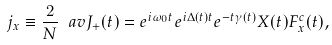Convert formula to latex. <formula><loc_0><loc_0><loc_500><loc_500>j _ { x } \equiv \frac { 2 } { N } \ a v { J _ { + } ( t ) } = e ^ { i \omega _ { 0 } t } e ^ { i \Delta ( t ) t } e ^ { - t \gamma ( t ) } X ( t ) F _ { x } ^ { c } ( t ) ,</formula> 